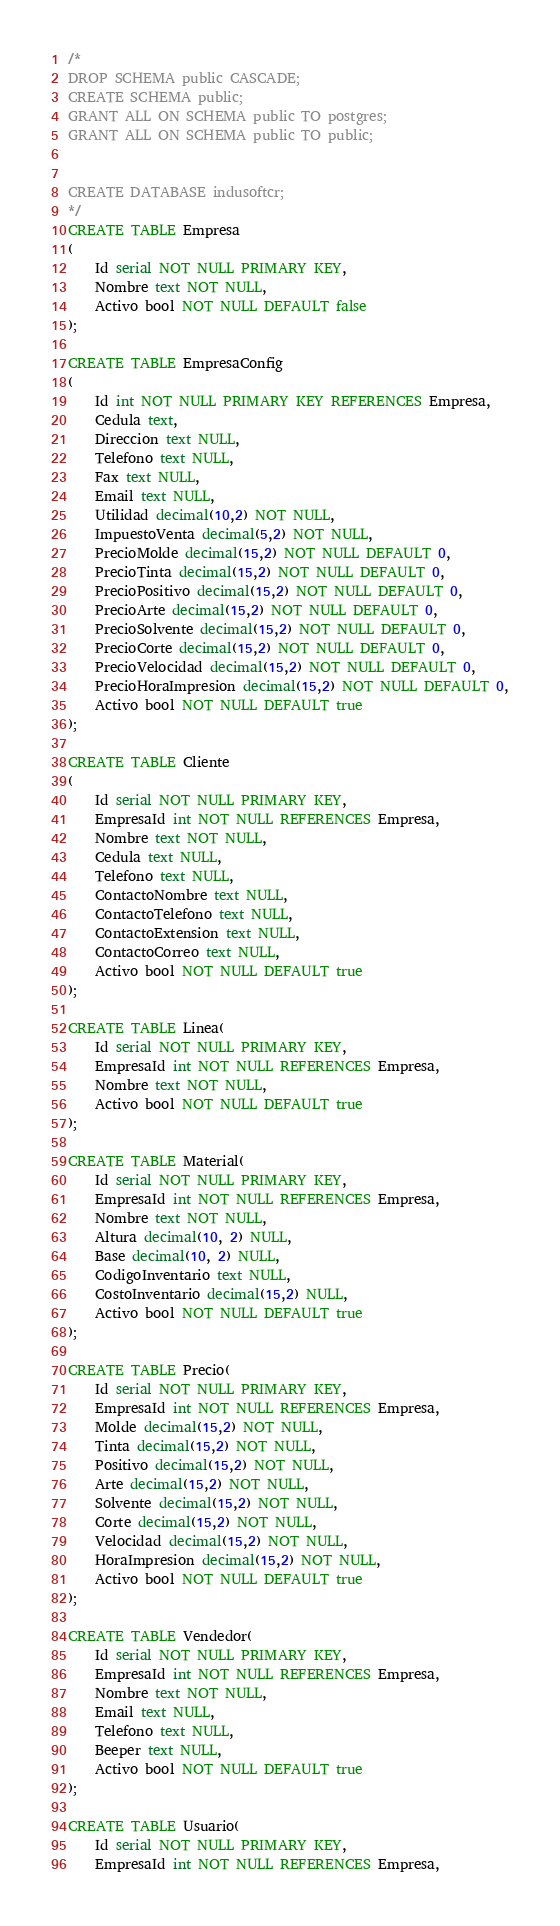<code> <loc_0><loc_0><loc_500><loc_500><_SQL_>/*
DROP SCHEMA public CASCADE;
CREATE SCHEMA public;
GRANT ALL ON SCHEMA public TO postgres;
GRANT ALL ON SCHEMA public TO public;


CREATE DATABASE indusoftcr;    
*/
CREATE TABLE Empresa
(
    Id serial NOT NULL PRIMARY KEY,
    Nombre text NOT NULL,
	Activo bool NOT NULL DEFAULT false
);

CREATE TABLE EmpresaConfig
(
    Id int NOT NULL PRIMARY KEY REFERENCES Empresa,
    Cedula text,
	Direccion text NULL,
	Telefono text NULL,
	Fax text NULL,
	Email text NULL,
	Utilidad decimal(10,2) NOT NULL,
	ImpuestoVenta decimal(5,2) NOT NULL,	
	PrecioMolde decimal(15,2) NOT NULL DEFAULT 0,
	PrecioTinta decimal(15,2) NOT NULL DEFAULT 0,
	PrecioPositivo decimal(15,2) NOT NULL DEFAULT 0,
	PrecioArte decimal(15,2) NOT NULL DEFAULT 0,
	PrecioSolvente decimal(15,2) NOT NULL DEFAULT 0,
	PrecioCorte decimal(15,2) NOT NULL DEFAULT 0,
	PrecioVelocidad decimal(15,2) NOT NULL DEFAULT 0,
	PrecioHoraImpresion decimal(15,2) NOT NULL DEFAULT 0,
	Activo bool NOT NULL DEFAULT true      
);

CREATE TABLE Cliente
(
	Id serial NOT NULL PRIMARY KEY,
	EmpresaId int NOT NULL REFERENCES Empresa,
    Nombre text NOT NULL,
	Cedula text NULL,
	Telefono text NULL,
	ContactoNombre text NULL,
	ContactoTelefono text NULL,
	ContactoExtension text NULL,
	ContactoCorreo text NULL,	
	Activo bool NOT NULL DEFAULT true
);

CREATE TABLE Linea(
	Id serial NOT NULL PRIMARY KEY,
	EmpresaId int NOT NULL REFERENCES Empresa,
    Nombre text NOT NULL,	
	Activo bool NOT NULL DEFAULT true
);

CREATE TABLE Material(
	Id serial NOT NULL PRIMARY KEY,
    EmpresaId int NOT NULL REFERENCES Empresa,
	Nombre text NOT NULL,
	Altura decimal(10, 2) NULL,
	Base decimal(10, 2) NULL,
	CodigoInventario text NULL,
	CostoInventario decimal(15,2) NULL,
	Activo bool NOT NULL DEFAULT true
);

CREATE TABLE Precio(
	Id serial NOT NULL PRIMARY KEY,
    EmpresaId int NOT NULL REFERENCES Empresa,
	Molde decimal(15,2) NOT NULL,
	Tinta decimal(15,2) NOT NULL,
	Positivo decimal(15,2) NOT NULL,
	Arte decimal(15,2) NOT NULL,
	Solvente decimal(15,2) NOT NULL,
	Corte decimal(15,2) NOT NULL,
	Velocidad decimal(15,2) NOT NULL,
	HoraImpresion decimal(15,2) NOT NULL,
	Activo bool NOT NULL DEFAULT true
);

CREATE TABLE Vendedor(
    Id serial NOT NULL PRIMARY KEY,
    EmpresaId int NOT NULL REFERENCES Empresa,
	Nombre text NOT NULL,
	Email text NULL,
	Telefono text NULL,
	Beeper text NULL,
	Activo bool NOT NULL DEFAULT true
);

CREATE TABLE Usuario(
    Id serial NOT NULL PRIMARY KEY,
    EmpresaId int NOT NULL REFERENCES Empresa,</code> 